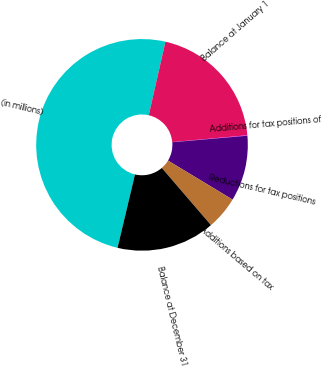Convert chart to OTSL. <chart><loc_0><loc_0><loc_500><loc_500><pie_chart><fcel>(in millions)<fcel>Balance at January 1<fcel>Additions for tax positions of<fcel>Reductions for tax positions<fcel>Additions based on tax<fcel>Balance at December 31<nl><fcel>49.85%<fcel>19.99%<fcel>0.07%<fcel>10.03%<fcel>5.05%<fcel>15.01%<nl></chart> 